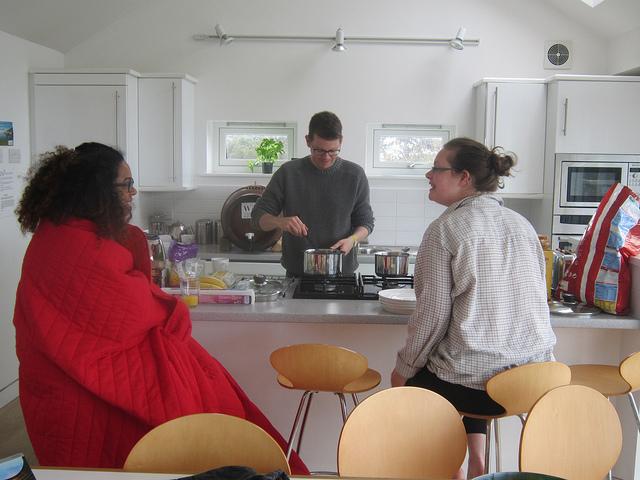Do the windows open?
Keep it brief. Yes. What is this room?
Quick response, please. Kitchen. How many chairs are there?
Short answer required. 6. 